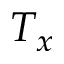<formula> <loc_0><loc_0><loc_500><loc_500>T _ { x }</formula> 